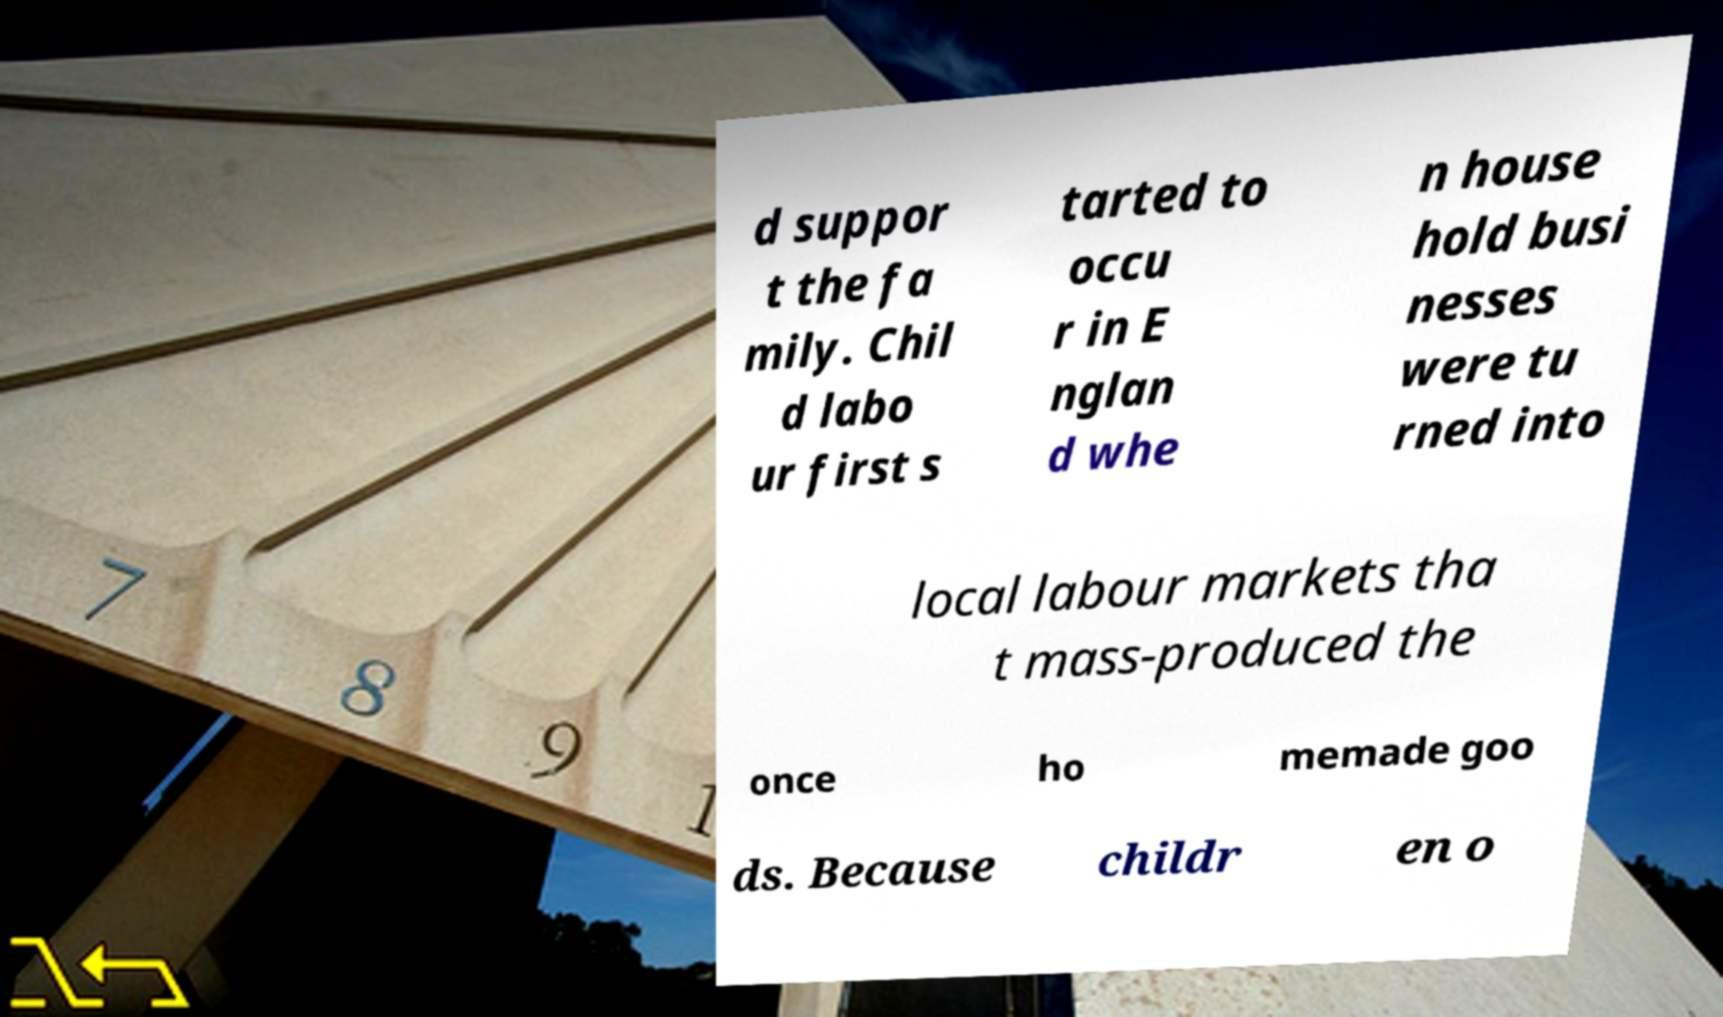Please identify and transcribe the text found in this image. d suppor t the fa mily. Chil d labo ur first s tarted to occu r in E nglan d whe n house hold busi nesses were tu rned into local labour markets tha t mass-produced the once ho memade goo ds. Because childr en o 